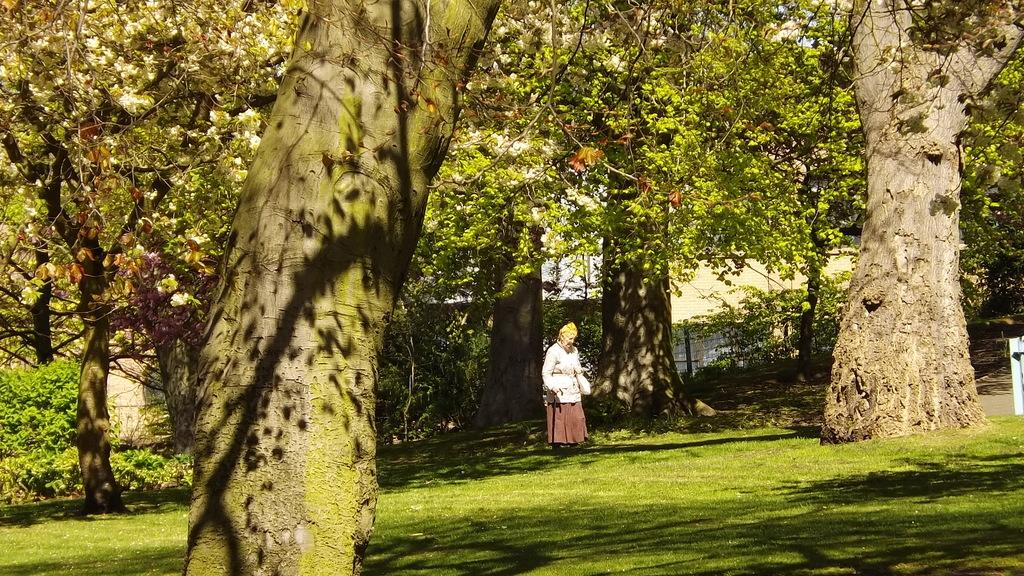What type of vegetation can be seen in the image? There are trees, plants, and grass in the image. What is the woman standing on in the image? The woman is standing on grass in the image. Can you describe the woman's surroundings in the image? The woman is surrounded by trees, plants, and grass in the image. What type of oven is visible in the image? There is no oven present in the image. Can you describe the mist surrounding the woman in the image? There is no mist visible in the image; it is a clear scene with the woman standing on grass surrounded by trees, plants, and grass. 